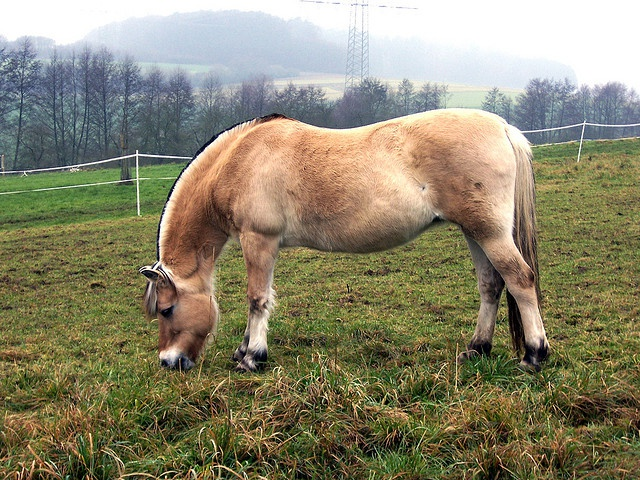Describe the objects in this image and their specific colors. I can see a horse in white, gray, and tan tones in this image. 